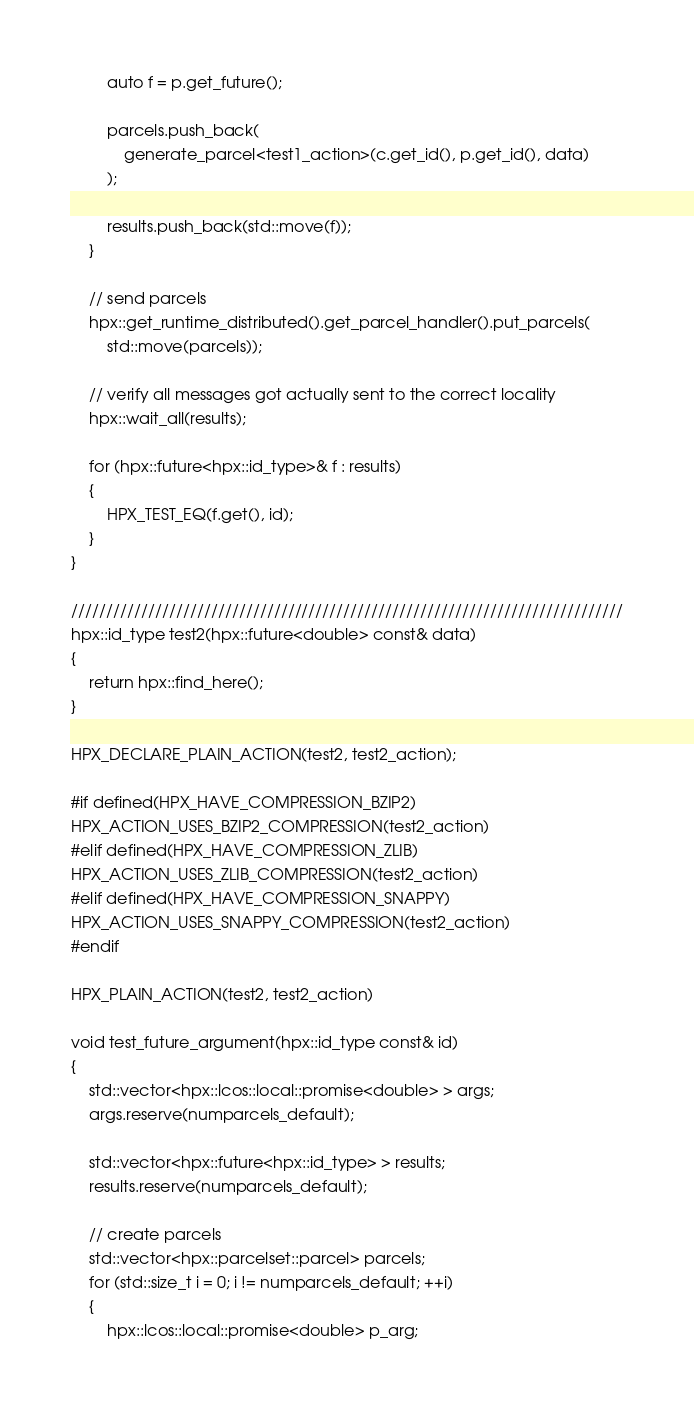<code> <loc_0><loc_0><loc_500><loc_500><_C++_>        auto f = p.get_future();

        parcels.push_back(
            generate_parcel<test1_action>(c.get_id(), p.get_id(), data)
        );

        results.push_back(std::move(f));
    }

    // send parcels
    hpx::get_runtime_distributed().get_parcel_handler().put_parcels(
        std::move(parcels));

    // verify all messages got actually sent to the correct locality
    hpx::wait_all(results);

    for (hpx::future<hpx::id_type>& f : results)
    {
        HPX_TEST_EQ(f.get(), id);
    }
}

///////////////////////////////////////////////////////////////////////////////
hpx::id_type test2(hpx::future<double> const& data)
{
    return hpx::find_here();
}

HPX_DECLARE_PLAIN_ACTION(test2, test2_action);

#if defined(HPX_HAVE_COMPRESSION_BZIP2)
HPX_ACTION_USES_BZIP2_COMPRESSION(test2_action)
#elif defined(HPX_HAVE_COMPRESSION_ZLIB)
HPX_ACTION_USES_ZLIB_COMPRESSION(test2_action)
#elif defined(HPX_HAVE_COMPRESSION_SNAPPY)
HPX_ACTION_USES_SNAPPY_COMPRESSION(test2_action)
#endif

HPX_PLAIN_ACTION(test2, test2_action)

void test_future_argument(hpx::id_type const& id)
{
    std::vector<hpx::lcos::local::promise<double> > args;
    args.reserve(numparcels_default);

    std::vector<hpx::future<hpx::id_type> > results;
    results.reserve(numparcels_default);

    // create parcels
    std::vector<hpx::parcelset::parcel> parcels;
    for (std::size_t i = 0; i != numparcels_default; ++i)
    {
        hpx::lcos::local::promise<double> p_arg;</code> 